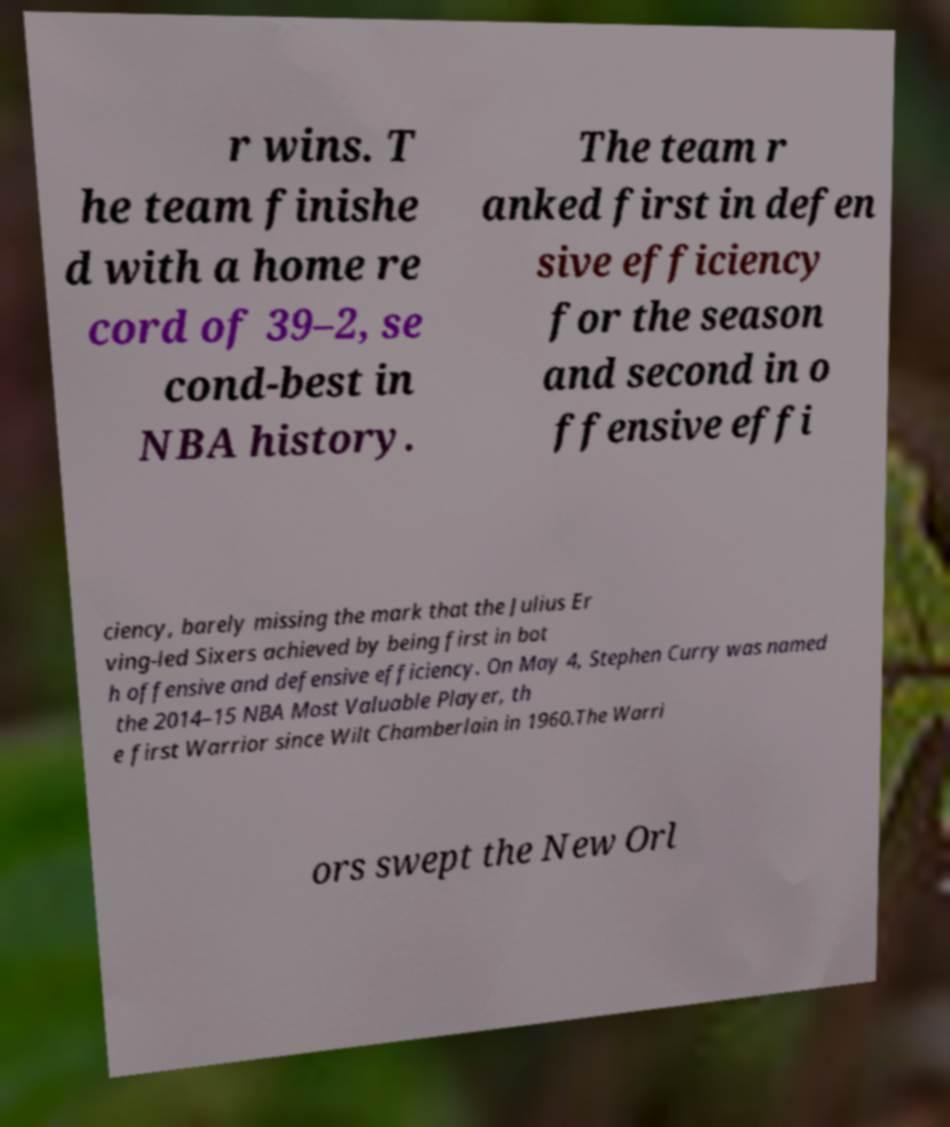Please identify and transcribe the text found in this image. r wins. T he team finishe d with a home re cord of 39–2, se cond-best in NBA history. The team r anked first in defen sive efficiency for the season and second in o ffensive effi ciency, barely missing the mark that the Julius Er ving-led Sixers achieved by being first in bot h offensive and defensive efficiency. On May 4, Stephen Curry was named the 2014–15 NBA Most Valuable Player, th e first Warrior since Wilt Chamberlain in 1960.The Warri ors swept the New Orl 